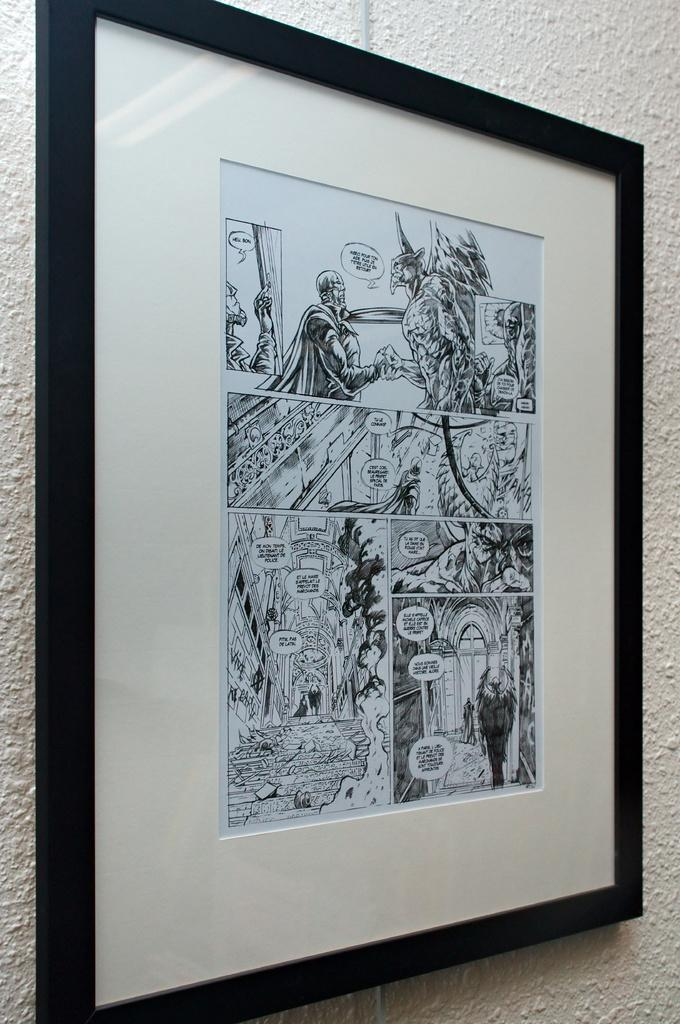What is hanging on the wall in the middle of the picture? There is a photo frame on the wall in the middle of the picture. What is inside the photo frame? The photo frame contains sketches. What type of religious ceremony is depicted in the sketches inside the photo frame? There is no indication of any religious ceremony in the sketches inside the photo frame. 